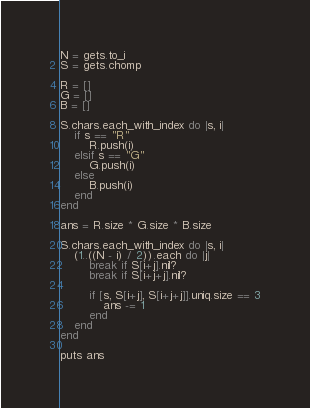Convert code to text. <code><loc_0><loc_0><loc_500><loc_500><_Ruby_>N = gets.to_i
S = gets.chomp

R = []
G = []
B = []

S.chars.each_with_index do |s, i|
    if s == "R"
        R.push(i)
    elsif s == "G"
        G.push(i)
    else
        B.push(i)
    end
end

ans = R.size * G.size * B.size

S.chars.each_with_index do |s, i|
    (1..((N - i) / 2)).each do |j|
        break if S[i+j].nil?
        break if S[i+j+j].nil?

        if [s, S[i+j], S[i+j+j]].uniq.size == 3
            ans -= 1
        end
    end
end

puts ans</code> 